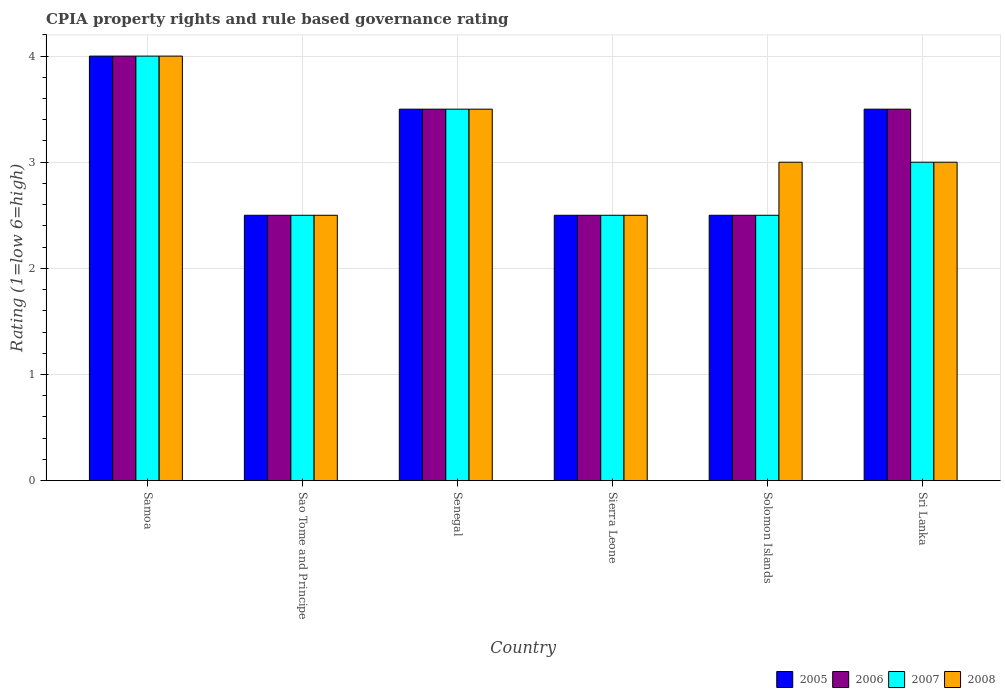How many different coloured bars are there?
Give a very brief answer. 4. Are the number of bars on each tick of the X-axis equal?
Give a very brief answer. Yes. How many bars are there on the 6th tick from the right?
Ensure brevity in your answer.  4. What is the label of the 4th group of bars from the left?
Your response must be concise. Sierra Leone. In how many cases, is the number of bars for a given country not equal to the number of legend labels?
Keep it short and to the point. 0. In which country was the CPIA rating in 2007 maximum?
Your answer should be very brief. Samoa. In which country was the CPIA rating in 2005 minimum?
Keep it short and to the point. Sao Tome and Principe. What is the total CPIA rating in 2008 in the graph?
Offer a very short reply. 18.5. What is the difference between the CPIA rating in 2008 in Samoa and the CPIA rating in 2006 in Sao Tome and Principe?
Your answer should be very brief. 1.5. What is the average CPIA rating in 2006 per country?
Ensure brevity in your answer.  3.08. What is the difference between the CPIA rating of/in 2007 and CPIA rating of/in 2005 in Solomon Islands?
Offer a terse response. 0. In how many countries, is the CPIA rating in 2005 greater than 3.2?
Your response must be concise. 3. What is the ratio of the CPIA rating in 2008 in Samoa to that in Solomon Islands?
Make the answer very short. 1.33. What is the difference between the highest and the lowest CPIA rating in 2007?
Offer a very short reply. 1.5. In how many countries, is the CPIA rating in 2008 greater than the average CPIA rating in 2008 taken over all countries?
Your response must be concise. 2. Is it the case that in every country, the sum of the CPIA rating in 2008 and CPIA rating in 2005 is greater than the sum of CPIA rating in 2006 and CPIA rating in 2007?
Your answer should be compact. No. What does the 1st bar from the right in Sierra Leone represents?
Offer a very short reply. 2008. Are all the bars in the graph horizontal?
Ensure brevity in your answer.  No. How many countries are there in the graph?
Your answer should be compact. 6. What is the difference between two consecutive major ticks on the Y-axis?
Offer a very short reply. 1. Are the values on the major ticks of Y-axis written in scientific E-notation?
Offer a very short reply. No. Does the graph contain any zero values?
Your answer should be very brief. No. How many legend labels are there?
Give a very brief answer. 4. How are the legend labels stacked?
Offer a terse response. Horizontal. What is the title of the graph?
Keep it short and to the point. CPIA property rights and rule based governance rating. Does "1966" appear as one of the legend labels in the graph?
Offer a very short reply. No. What is the label or title of the X-axis?
Provide a short and direct response. Country. What is the label or title of the Y-axis?
Offer a very short reply. Rating (1=low 6=high). What is the Rating (1=low 6=high) of 2007 in Samoa?
Your answer should be compact. 4. What is the Rating (1=low 6=high) in 2007 in Sao Tome and Principe?
Ensure brevity in your answer.  2.5. What is the Rating (1=low 6=high) of 2005 in Senegal?
Ensure brevity in your answer.  3.5. What is the Rating (1=low 6=high) of 2008 in Senegal?
Your answer should be compact. 3.5. What is the Rating (1=low 6=high) of 2007 in Sierra Leone?
Offer a very short reply. 2.5. What is the Rating (1=low 6=high) of 2007 in Solomon Islands?
Ensure brevity in your answer.  2.5. What is the Rating (1=low 6=high) in 2006 in Sri Lanka?
Your answer should be compact. 3.5. What is the Rating (1=low 6=high) of 2007 in Sri Lanka?
Your response must be concise. 3. What is the Rating (1=low 6=high) of 2008 in Sri Lanka?
Your answer should be compact. 3. Across all countries, what is the maximum Rating (1=low 6=high) in 2006?
Offer a very short reply. 4. Across all countries, what is the maximum Rating (1=low 6=high) in 2008?
Give a very brief answer. 4. Across all countries, what is the minimum Rating (1=low 6=high) in 2006?
Your answer should be very brief. 2.5. What is the total Rating (1=low 6=high) of 2005 in the graph?
Provide a short and direct response. 18.5. What is the difference between the Rating (1=low 6=high) in 2006 in Samoa and that in Sao Tome and Principe?
Offer a very short reply. 1.5. What is the difference between the Rating (1=low 6=high) in 2008 in Samoa and that in Sao Tome and Principe?
Provide a short and direct response. 1.5. What is the difference between the Rating (1=low 6=high) of 2005 in Samoa and that in Senegal?
Ensure brevity in your answer.  0.5. What is the difference between the Rating (1=low 6=high) in 2007 in Samoa and that in Senegal?
Provide a succinct answer. 0.5. What is the difference between the Rating (1=low 6=high) of 2008 in Samoa and that in Senegal?
Ensure brevity in your answer.  0.5. What is the difference between the Rating (1=low 6=high) of 2005 in Samoa and that in Sierra Leone?
Your response must be concise. 1.5. What is the difference between the Rating (1=low 6=high) in 2006 in Samoa and that in Sierra Leone?
Provide a succinct answer. 1.5. What is the difference between the Rating (1=low 6=high) of 2007 in Samoa and that in Sierra Leone?
Make the answer very short. 1.5. What is the difference between the Rating (1=low 6=high) in 2007 in Samoa and that in Solomon Islands?
Your answer should be compact. 1.5. What is the difference between the Rating (1=low 6=high) of 2008 in Samoa and that in Solomon Islands?
Offer a terse response. 1. What is the difference between the Rating (1=low 6=high) in 2007 in Samoa and that in Sri Lanka?
Provide a succinct answer. 1. What is the difference between the Rating (1=low 6=high) of 2005 in Sao Tome and Principe and that in Senegal?
Provide a succinct answer. -1. What is the difference between the Rating (1=low 6=high) in 2007 in Sao Tome and Principe and that in Senegal?
Offer a very short reply. -1. What is the difference between the Rating (1=low 6=high) of 2006 in Sao Tome and Principe and that in Sierra Leone?
Your answer should be very brief. 0. What is the difference between the Rating (1=low 6=high) of 2008 in Sao Tome and Principe and that in Sierra Leone?
Your answer should be very brief. 0. What is the difference between the Rating (1=low 6=high) of 2007 in Sao Tome and Principe and that in Solomon Islands?
Offer a terse response. 0. What is the difference between the Rating (1=low 6=high) in 2008 in Sao Tome and Principe and that in Solomon Islands?
Your response must be concise. -0.5. What is the difference between the Rating (1=low 6=high) in 2005 in Sao Tome and Principe and that in Sri Lanka?
Your answer should be compact. -1. What is the difference between the Rating (1=low 6=high) of 2006 in Sao Tome and Principe and that in Sri Lanka?
Your response must be concise. -1. What is the difference between the Rating (1=low 6=high) in 2008 in Sao Tome and Principe and that in Sri Lanka?
Ensure brevity in your answer.  -0.5. What is the difference between the Rating (1=low 6=high) of 2005 in Senegal and that in Sierra Leone?
Your answer should be compact. 1. What is the difference between the Rating (1=low 6=high) in 2006 in Senegal and that in Sierra Leone?
Your answer should be very brief. 1. What is the difference between the Rating (1=low 6=high) in 2005 in Senegal and that in Solomon Islands?
Give a very brief answer. 1. What is the difference between the Rating (1=low 6=high) in 2006 in Senegal and that in Solomon Islands?
Offer a terse response. 1. What is the difference between the Rating (1=low 6=high) of 2008 in Senegal and that in Solomon Islands?
Your response must be concise. 0.5. What is the difference between the Rating (1=low 6=high) of 2007 in Senegal and that in Sri Lanka?
Keep it short and to the point. 0.5. What is the difference between the Rating (1=low 6=high) in 2006 in Sierra Leone and that in Solomon Islands?
Offer a terse response. 0. What is the difference between the Rating (1=low 6=high) of 2007 in Sierra Leone and that in Solomon Islands?
Offer a terse response. 0. What is the difference between the Rating (1=low 6=high) in 2008 in Sierra Leone and that in Solomon Islands?
Provide a succinct answer. -0.5. What is the difference between the Rating (1=low 6=high) in 2005 in Sierra Leone and that in Sri Lanka?
Keep it short and to the point. -1. What is the difference between the Rating (1=low 6=high) of 2006 in Sierra Leone and that in Sri Lanka?
Offer a terse response. -1. What is the difference between the Rating (1=low 6=high) in 2006 in Solomon Islands and that in Sri Lanka?
Your response must be concise. -1. What is the difference between the Rating (1=low 6=high) of 2005 in Samoa and the Rating (1=low 6=high) of 2008 in Sao Tome and Principe?
Your response must be concise. 1.5. What is the difference between the Rating (1=low 6=high) in 2005 in Samoa and the Rating (1=low 6=high) in 2008 in Senegal?
Ensure brevity in your answer.  0.5. What is the difference between the Rating (1=low 6=high) of 2006 in Samoa and the Rating (1=low 6=high) of 2007 in Senegal?
Keep it short and to the point. 0.5. What is the difference between the Rating (1=low 6=high) in 2006 in Samoa and the Rating (1=low 6=high) in 2008 in Senegal?
Ensure brevity in your answer.  0.5. What is the difference between the Rating (1=low 6=high) of 2007 in Samoa and the Rating (1=low 6=high) of 2008 in Senegal?
Give a very brief answer. 0.5. What is the difference between the Rating (1=low 6=high) of 2005 in Samoa and the Rating (1=low 6=high) of 2007 in Sierra Leone?
Offer a terse response. 1.5. What is the difference between the Rating (1=low 6=high) of 2005 in Samoa and the Rating (1=low 6=high) of 2008 in Sierra Leone?
Give a very brief answer. 1.5. What is the difference between the Rating (1=low 6=high) of 2006 in Samoa and the Rating (1=low 6=high) of 2007 in Sierra Leone?
Provide a short and direct response. 1.5. What is the difference between the Rating (1=low 6=high) in 2005 in Samoa and the Rating (1=low 6=high) in 2007 in Solomon Islands?
Give a very brief answer. 1.5. What is the difference between the Rating (1=low 6=high) in 2005 in Samoa and the Rating (1=low 6=high) in 2008 in Solomon Islands?
Your response must be concise. 1. What is the difference between the Rating (1=low 6=high) in 2006 in Samoa and the Rating (1=low 6=high) in 2007 in Solomon Islands?
Make the answer very short. 1.5. What is the difference between the Rating (1=low 6=high) in 2006 in Samoa and the Rating (1=low 6=high) in 2008 in Solomon Islands?
Keep it short and to the point. 1. What is the difference between the Rating (1=low 6=high) in 2007 in Samoa and the Rating (1=low 6=high) in 2008 in Solomon Islands?
Ensure brevity in your answer.  1. What is the difference between the Rating (1=low 6=high) in 2005 in Samoa and the Rating (1=low 6=high) in 2008 in Sri Lanka?
Give a very brief answer. 1. What is the difference between the Rating (1=low 6=high) of 2006 in Samoa and the Rating (1=low 6=high) of 2007 in Sri Lanka?
Provide a short and direct response. 1. What is the difference between the Rating (1=low 6=high) in 2007 in Samoa and the Rating (1=low 6=high) in 2008 in Sri Lanka?
Your answer should be very brief. 1. What is the difference between the Rating (1=low 6=high) in 2005 in Sao Tome and Principe and the Rating (1=low 6=high) in 2008 in Senegal?
Provide a short and direct response. -1. What is the difference between the Rating (1=low 6=high) of 2006 in Sao Tome and Principe and the Rating (1=low 6=high) of 2007 in Senegal?
Your answer should be compact. -1. What is the difference between the Rating (1=low 6=high) in 2005 in Sao Tome and Principe and the Rating (1=low 6=high) in 2006 in Sierra Leone?
Your answer should be very brief. 0. What is the difference between the Rating (1=low 6=high) in 2005 in Sao Tome and Principe and the Rating (1=low 6=high) in 2007 in Sierra Leone?
Your response must be concise. 0. What is the difference between the Rating (1=low 6=high) in 2005 in Sao Tome and Principe and the Rating (1=low 6=high) in 2008 in Sierra Leone?
Your answer should be very brief. 0. What is the difference between the Rating (1=low 6=high) of 2006 in Sao Tome and Principe and the Rating (1=low 6=high) of 2008 in Sierra Leone?
Provide a short and direct response. 0. What is the difference between the Rating (1=low 6=high) in 2005 in Sao Tome and Principe and the Rating (1=low 6=high) in 2006 in Solomon Islands?
Keep it short and to the point. 0. What is the difference between the Rating (1=low 6=high) in 2005 in Sao Tome and Principe and the Rating (1=low 6=high) in 2007 in Solomon Islands?
Your answer should be very brief. 0. What is the difference between the Rating (1=low 6=high) in 2005 in Sao Tome and Principe and the Rating (1=low 6=high) in 2008 in Solomon Islands?
Keep it short and to the point. -0.5. What is the difference between the Rating (1=low 6=high) of 2005 in Sao Tome and Principe and the Rating (1=low 6=high) of 2006 in Sri Lanka?
Offer a very short reply. -1. What is the difference between the Rating (1=low 6=high) of 2005 in Sao Tome and Principe and the Rating (1=low 6=high) of 2007 in Sri Lanka?
Offer a very short reply. -0.5. What is the difference between the Rating (1=low 6=high) of 2006 in Sao Tome and Principe and the Rating (1=low 6=high) of 2007 in Sri Lanka?
Offer a very short reply. -0.5. What is the difference between the Rating (1=low 6=high) of 2006 in Sao Tome and Principe and the Rating (1=low 6=high) of 2008 in Sri Lanka?
Ensure brevity in your answer.  -0.5. What is the difference between the Rating (1=low 6=high) in 2005 in Senegal and the Rating (1=low 6=high) in 2007 in Sierra Leone?
Your answer should be compact. 1. What is the difference between the Rating (1=low 6=high) in 2005 in Senegal and the Rating (1=low 6=high) in 2008 in Sierra Leone?
Provide a short and direct response. 1. What is the difference between the Rating (1=low 6=high) in 2006 in Senegal and the Rating (1=low 6=high) in 2008 in Sierra Leone?
Keep it short and to the point. 1. What is the difference between the Rating (1=low 6=high) in 2005 in Senegal and the Rating (1=low 6=high) in 2008 in Solomon Islands?
Keep it short and to the point. 0.5. What is the difference between the Rating (1=low 6=high) of 2006 in Senegal and the Rating (1=low 6=high) of 2008 in Solomon Islands?
Keep it short and to the point. 0.5. What is the difference between the Rating (1=low 6=high) of 2006 in Senegal and the Rating (1=low 6=high) of 2007 in Sri Lanka?
Give a very brief answer. 0.5. What is the difference between the Rating (1=low 6=high) in 2006 in Senegal and the Rating (1=low 6=high) in 2008 in Sri Lanka?
Your answer should be compact. 0.5. What is the difference between the Rating (1=low 6=high) of 2007 in Senegal and the Rating (1=low 6=high) of 2008 in Sri Lanka?
Your answer should be very brief. 0.5. What is the difference between the Rating (1=low 6=high) in 2005 in Sierra Leone and the Rating (1=low 6=high) in 2006 in Solomon Islands?
Give a very brief answer. 0. What is the difference between the Rating (1=low 6=high) in 2005 in Sierra Leone and the Rating (1=low 6=high) in 2007 in Solomon Islands?
Your answer should be compact. 0. What is the difference between the Rating (1=low 6=high) of 2005 in Sierra Leone and the Rating (1=low 6=high) of 2008 in Solomon Islands?
Make the answer very short. -0.5. What is the difference between the Rating (1=low 6=high) of 2007 in Sierra Leone and the Rating (1=low 6=high) of 2008 in Solomon Islands?
Provide a short and direct response. -0.5. What is the difference between the Rating (1=low 6=high) of 2005 in Sierra Leone and the Rating (1=low 6=high) of 2006 in Sri Lanka?
Provide a short and direct response. -1. What is the difference between the Rating (1=low 6=high) of 2005 in Sierra Leone and the Rating (1=low 6=high) of 2008 in Sri Lanka?
Offer a terse response. -0.5. What is the difference between the Rating (1=low 6=high) in 2006 in Sierra Leone and the Rating (1=low 6=high) in 2007 in Sri Lanka?
Give a very brief answer. -0.5. What is the difference between the Rating (1=low 6=high) in 2006 in Sierra Leone and the Rating (1=low 6=high) in 2008 in Sri Lanka?
Make the answer very short. -0.5. What is the difference between the Rating (1=low 6=high) in 2007 in Sierra Leone and the Rating (1=low 6=high) in 2008 in Sri Lanka?
Give a very brief answer. -0.5. What is the difference between the Rating (1=low 6=high) of 2005 in Solomon Islands and the Rating (1=low 6=high) of 2006 in Sri Lanka?
Offer a terse response. -1. What is the difference between the Rating (1=low 6=high) of 2005 in Solomon Islands and the Rating (1=low 6=high) of 2007 in Sri Lanka?
Make the answer very short. -0.5. What is the difference between the Rating (1=low 6=high) of 2005 in Solomon Islands and the Rating (1=low 6=high) of 2008 in Sri Lanka?
Your answer should be very brief. -0.5. What is the difference between the Rating (1=low 6=high) of 2007 in Solomon Islands and the Rating (1=low 6=high) of 2008 in Sri Lanka?
Your response must be concise. -0.5. What is the average Rating (1=low 6=high) of 2005 per country?
Provide a succinct answer. 3.08. What is the average Rating (1=low 6=high) in 2006 per country?
Give a very brief answer. 3.08. What is the average Rating (1=low 6=high) of 2007 per country?
Your answer should be very brief. 3. What is the average Rating (1=low 6=high) in 2008 per country?
Keep it short and to the point. 3.08. What is the difference between the Rating (1=low 6=high) in 2005 and Rating (1=low 6=high) in 2007 in Samoa?
Ensure brevity in your answer.  0. What is the difference between the Rating (1=low 6=high) in 2006 and Rating (1=low 6=high) in 2007 in Samoa?
Offer a terse response. 0. What is the difference between the Rating (1=low 6=high) in 2005 and Rating (1=low 6=high) in 2007 in Sao Tome and Principe?
Offer a very short reply. 0. What is the difference between the Rating (1=low 6=high) of 2006 and Rating (1=low 6=high) of 2007 in Sao Tome and Principe?
Ensure brevity in your answer.  0. What is the difference between the Rating (1=low 6=high) in 2007 and Rating (1=low 6=high) in 2008 in Sao Tome and Principe?
Offer a very short reply. 0. What is the difference between the Rating (1=low 6=high) in 2005 and Rating (1=low 6=high) in 2006 in Senegal?
Keep it short and to the point. 0. What is the difference between the Rating (1=low 6=high) in 2005 and Rating (1=low 6=high) in 2008 in Senegal?
Make the answer very short. 0. What is the difference between the Rating (1=low 6=high) of 2006 and Rating (1=low 6=high) of 2007 in Senegal?
Give a very brief answer. 0. What is the difference between the Rating (1=low 6=high) in 2006 and Rating (1=low 6=high) in 2008 in Senegal?
Offer a terse response. 0. What is the difference between the Rating (1=low 6=high) of 2007 and Rating (1=low 6=high) of 2008 in Senegal?
Your answer should be very brief. 0. What is the difference between the Rating (1=low 6=high) of 2005 and Rating (1=low 6=high) of 2006 in Sierra Leone?
Provide a short and direct response. 0. What is the difference between the Rating (1=low 6=high) of 2005 and Rating (1=low 6=high) of 2008 in Sierra Leone?
Your answer should be compact. 0. What is the difference between the Rating (1=low 6=high) of 2006 and Rating (1=low 6=high) of 2007 in Sierra Leone?
Make the answer very short. 0. What is the difference between the Rating (1=low 6=high) of 2006 and Rating (1=low 6=high) of 2008 in Sierra Leone?
Your response must be concise. 0. What is the difference between the Rating (1=low 6=high) in 2007 and Rating (1=low 6=high) in 2008 in Sierra Leone?
Your answer should be compact. 0. What is the difference between the Rating (1=low 6=high) of 2005 and Rating (1=low 6=high) of 2006 in Solomon Islands?
Provide a short and direct response. 0. What is the difference between the Rating (1=low 6=high) in 2006 and Rating (1=low 6=high) in 2008 in Solomon Islands?
Provide a short and direct response. -0.5. What is the difference between the Rating (1=low 6=high) of 2007 and Rating (1=low 6=high) of 2008 in Solomon Islands?
Keep it short and to the point. -0.5. What is the difference between the Rating (1=low 6=high) in 2005 and Rating (1=low 6=high) in 2006 in Sri Lanka?
Your response must be concise. 0. What is the difference between the Rating (1=low 6=high) in 2005 and Rating (1=low 6=high) in 2007 in Sri Lanka?
Ensure brevity in your answer.  0.5. What is the difference between the Rating (1=low 6=high) in 2005 and Rating (1=low 6=high) in 2008 in Sri Lanka?
Provide a succinct answer. 0.5. What is the difference between the Rating (1=low 6=high) in 2006 and Rating (1=low 6=high) in 2007 in Sri Lanka?
Offer a very short reply. 0.5. What is the difference between the Rating (1=low 6=high) in 2007 and Rating (1=low 6=high) in 2008 in Sri Lanka?
Keep it short and to the point. 0. What is the ratio of the Rating (1=low 6=high) of 2005 in Samoa to that in Sao Tome and Principe?
Provide a short and direct response. 1.6. What is the ratio of the Rating (1=low 6=high) of 2007 in Samoa to that in Sao Tome and Principe?
Give a very brief answer. 1.6. What is the ratio of the Rating (1=low 6=high) in 2008 in Samoa to that in Sao Tome and Principe?
Make the answer very short. 1.6. What is the ratio of the Rating (1=low 6=high) in 2006 in Samoa to that in Senegal?
Provide a short and direct response. 1.14. What is the ratio of the Rating (1=low 6=high) in 2007 in Samoa to that in Senegal?
Your response must be concise. 1.14. What is the ratio of the Rating (1=low 6=high) of 2008 in Samoa to that in Senegal?
Ensure brevity in your answer.  1.14. What is the ratio of the Rating (1=low 6=high) of 2005 in Samoa to that in Sierra Leone?
Offer a terse response. 1.6. What is the ratio of the Rating (1=low 6=high) of 2006 in Samoa to that in Sierra Leone?
Your answer should be very brief. 1.6. What is the ratio of the Rating (1=low 6=high) in 2007 in Samoa to that in Sierra Leone?
Offer a very short reply. 1.6. What is the ratio of the Rating (1=low 6=high) of 2008 in Samoa to that in Sierra Leone?
Give a very brief answer. 1.6. What is the ratio of the Rating (1=low 6=high) of 2005 in Samoa to that in Solomon Islands?
Offer a very short reply. 1.6. What is the ratio of the Rating (1=low 6=high) in 2007 in Samoa to that in Solomon Islands?
Make the answer very short. 1.6. What is the ratio of the Rating (1=low 6=high) in 2008 in Samoa to that in Solomon Islands?
Provide a short and direct response. 1.33. What is the ratio of the Rating (1=low 6=high) of 2008 in Samoa to that in Sri Lanka?
Keep it short and to the point. 1.33. What is the ratio of the Rating (1=low 6=high) in 2005 in Sao Tome and Principe to that in Senegal?
Give a very brief answer. 0.71. What is the ratio of the Rating (1=low 6=high) in 2006 in Sao Tome and Principe to that in Senegal?
Offer a very short reply. 0.71. What is the ratio of the Rating (1=low 6=high) of 2007 in Sao Tome and Principe to that in Senegal?
Your answer should be very brief. 0.71. What is the ratio of the Rating (1=low 6=high) in 2008 in Sao Tome and Principe to that in Senegal?
Your answer should be compact. 0.71. What is the ratio of the Rating (1=low 6=high) of 2005 in Sao Tome and Principe to that in Sierra Leone?
Your answer should be compact. 1. What is the ratio of the Rating (1=low 6=high) in 2007 in Sao Tome and Principe to that in Sierra Leone?
Ensure brevity in your answer.  1. What is the ratio of the Rating (1=low 6=high) of 2005 in Sao Tome and Principe to that in Solomon Islands?
Provide a succinct answer. 1. What is the ratio of the Rating (1=low 6=high) in 2006 in Sao Tome and Principe to that in Solomon Islands?
Your response must be concise. 1. What is the ratio of the Rating (1=low 6=high) of 2006 in Sao Tome and Principe to that in Sri Lanka?
Your answer should be compact. 0.71. What is the ratio of the Rating (1=low 6=high) of 2007 in Sao Tome and Principe to that in Sri Lanka?
Your response must be concise. 0.83. What is the ratio of the Rating (1=low 6=high) in 2008 in Sao Tome and Principe to that in Sri Lanka?
Offer a very short reply. 0.83. What is the ratio of the Rating (1=low 6=high) in 2006 in Senegal to that in Sierra Leone?
Provide a short and direct response. 1.4. What is the ratio of the Rating (1=low 6=high) in 2005 in Senegal to that in Sri Lanka?
Your response must be concise. 1. What is the ratio of the Rating (1=low 6=high) in 2006 in Senegal to that in Sri Lanka?
Offer a terse response. 1. What is the ratio of the Rating (1=low 6=high) of 2007 in Senegal to that in Sri Lanka?
Provide a short and direct response. 1.17. What is the ratio of the Rating (1=low 6=high) in 2005 in Sierra Leone to that in Solomon Islands?
Make the answer very short. 1. What is the ratio of the Rating (1=low 6=high) in 2008 in Sierra Leone to that in Solomon Islands?
Your response must be concise. 0.83. What is the ratio of the Rating (1=low 6=high) of 2007 in Sierra Leone to that in Sri Lanka?
Your answer should be very brief. 0.83. What is the ratio of the Rating (1=low 6=high) in 2005 in Solomon Islands to that in Sri Lanka?
Offer a terse response. 0.71. What is the ratio of the Rating (1=low 6=high) of 2006 in Solomon Islands to that in Sri Lanka?
Provide a short and direct response. 0.71. What is the ratio of the Rating (1=low 6=high) of 2007 in Solomon Islands to that in Sri Lanka?
Offer a terse response. 0.83. What is the difference between the highest and the second highest Rating (1=low 6=high) of 2005?
Give a very brief answer. 0.5. What is the difference between the highest and the second highest Rating (1=low 6=high) in 2007?
Ensure brevity in your answer.  0.5. What is the difference between the highest and the lowest Rating (1=low 6=high) of 2007?
Offer a terse response. 1.5. What is the difference between the highest and the lowest Rating (1=low 6=high) of 2008?
Your answer should be very brief. 1.5. 